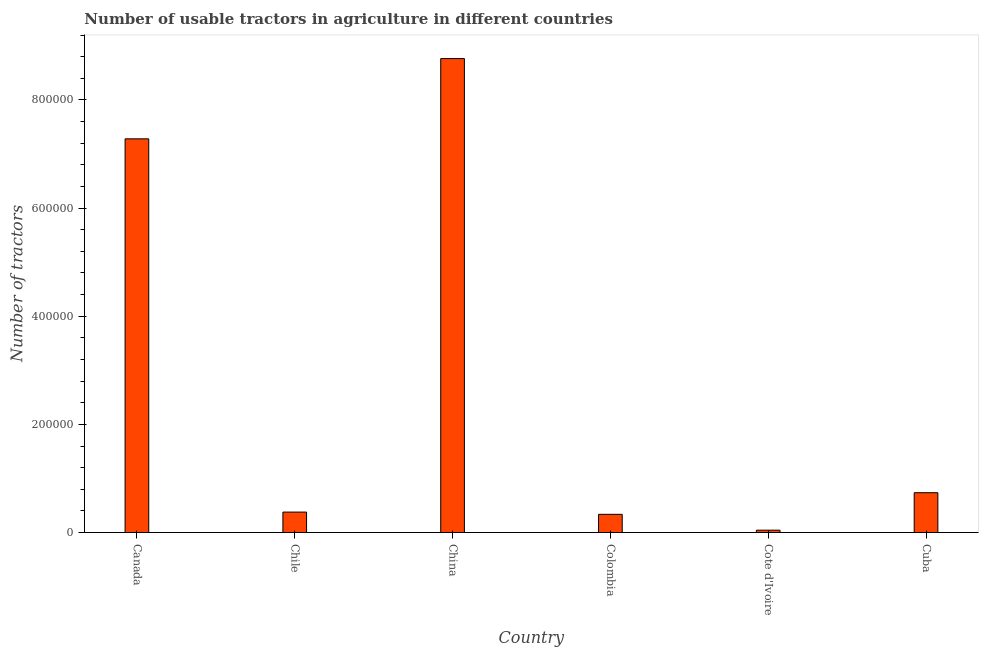Does the graph contain any zero values?
Provide a short and direct response. No. What is the title of the graph?
Your answer should be very brief. Number of usable tractors in agriculture in different countries. What is the label or title of the Y-axis?
Give a very brief answer. Number of tractors. What is the number of tractors in China?
Your response must be concise. 8.76e+05. Across all countries, what is the maximum number of tractors?
Provide a short and direct response. 8.76e+05. Across all countries, what is the minimum number of tractors?
Make the answer very short. 4470. In which country was the number of tractors maximum?
Offer a very short reply. China. In which country was the number of tractors minimum?
Give a very brief answer. Cote d'Ivoire. What is the sum of the number of tractors?
Offer a very short reply. 1.75e+06. What is the difference between the number of tractors in China and Colombia?
Your answer should be very brief. 8.43e+05. What is the average number of tractors per country?
Keep it short and to the point. 2.92e+05. What is the median number of tractors?
Offer a very short reply. 5.58e+04. What is the ratio of the number of tractors in Canada to that in Colombia?
Keep it short and to the point. 21.57. Is the number of tractors in Colombia less than that in Cote d'Ivoire?
Give a very brief answer. No. Is the difference between the number of tractors in Chile and Cuba greater than the difference between any two countries?
Ensure brevity in your answer.  No. What is the difference between the highest and the second highest number of tractors?
Make the answer very short. 1.48e+05. Is the sum of the number of tractors in Canada and Colombia greater than the maximum number of tractors across all countries?
Provide a succinct answer. No. What is the difference between the highest and the lowest number of tractors?
Provide a succinct answer. 8.72e+05. In how many countries, is the number of tractors greater than the average number of tractors taken over all countries?
Your answer should be very brief. 2. Are all the bars in the graph horizontal?
Provide a short and direct response. No. How many countries are there in the graph?
Keep it short and to the point. 6. What is the Number of tractors of Canada?
Your answer should be very brief. 7.28e+05. What is the Number of tractors of Chile?
Offer a very short reply. 3.79e+04. What is the Number of tractors in China?
Ensure brevity in your answer.  8.76e+05. What is the Number of tractors of Colombia?
Your answer should be very brief. 3.38e+04. What is the Number of tractors in Cote d'Ivoire?
Make the answer very short. 4470. What is the Number of tractors in Cuba?
Your answer should be very brief. 7.37e+04. What is the difference between the Number of tractors in Canada and Chile?
Provide a short and direct response. 6.90e+05. What is the difference between the Number of tractors in Canada and China?
Provide a short and direct response. -1.48e+05. What is the difference between the Number of tractors in Canada and Colombia?
Your answer should be compact. 6.94e+05. What is the difference between the Number of tractors in Canada and Cote d'Ivoire?
Provide a short and direct response. 7.24e+05. What is the difference between the Number of tractors in Canada and Cuba?
Make the answer very short. 6.54e+05. What is the difference between the Number of tractors in Chile and China?
Provide a succinct answer. -8.39e+05. What is the difference between the Number of tractors in Chile and Colombia?
Your answer should be compact. 4163. What is the difference between the Number of tractors in Chile and Cote d'Ivoire?
Offer a very short reply. 3.34e+04. What is the difference between the Number of tractors in Chile and Cuba?
Keep it short and to the point. -3.58e+04. What is the difference between the Number of tractors in China and Colombia?
Your answer should be compact. 8.43e+05. What is the difference between the Number of tractors in China and Cote d'Ivoire?
Give a very brief answer. 8.72e+05. What is the difference between the Number of tractors in China and Cuba?
Offer a very short reply. 8.03e+05. What is the difference between the Number of tractors in Colombia and Cote d'Ivoire?
Your response must be concise. 2.93e+04. What is the difference between the Number of tractors in Colombia and Cuba?
Your answer should be compact. -4.00e+04. What is the difference between the Number of tractors in Cote d'Ivoire and Cuba?
Provide a succinct answer. -6.93e+04. What is the ratio of the Number of tractors in Canada to that in China?
Keep it short and to the point. 0.83. What is the ratio of the Number of tractors in Canada to that in Colombia?
Your answer should be compact. 21.57. What is the ratio of the Number of tractors in Canada to that in Cote d'Ivoire?
Your answer should be compact. 162.88. What is the ratio of the Number of tractors in Canada to that in Cuba?
Provide a succinct answer. 9.87. What is the ratio of the Number of tractors in Chile to that in China?
Provide a short and direct response. 0.04. What is the ratio of the Number of tractors in Chile to that in Colombia?
Your answer should be very brief. 1.12. What is the ratio of the Number of tractors in Chile to that in Cote d'Ivoire?
Keep it short and to the point. 8.48. What is the ratio of the Number of tractors in Chile to that in Cuba?
Keep it short and to the point. 0.51. What is the ratio of the Number of tractors in China to that in Colombia?
Give a very brief answer. 25.96. What is the ratio of the Number of tractors in China to that in Cote d'Ivoire?
Offer a very short reply. 196.08. What is the ratio of the Number of tractors in China to that in Cuba?
Your response must be concise. 11.89. What is the ratio of the Number of tractors in Colombia to that in Cote d'Ivoire?
Your answer should be compact. 7.55. What is the ratio of the Number of tractors in Colombia to that in Cuba?
Ensure brevity in your answer.  0.46. What is the ratio of the Number of tractors in Cote d'Ivoire to that in Cuba?
Offer a very short reply. 0.06. 